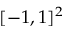Convert formula to latex. <formula><loc_0><loc_0><loc_500><loc_500>[ - 1 , 1 ] ^ { 2 }</formula> 